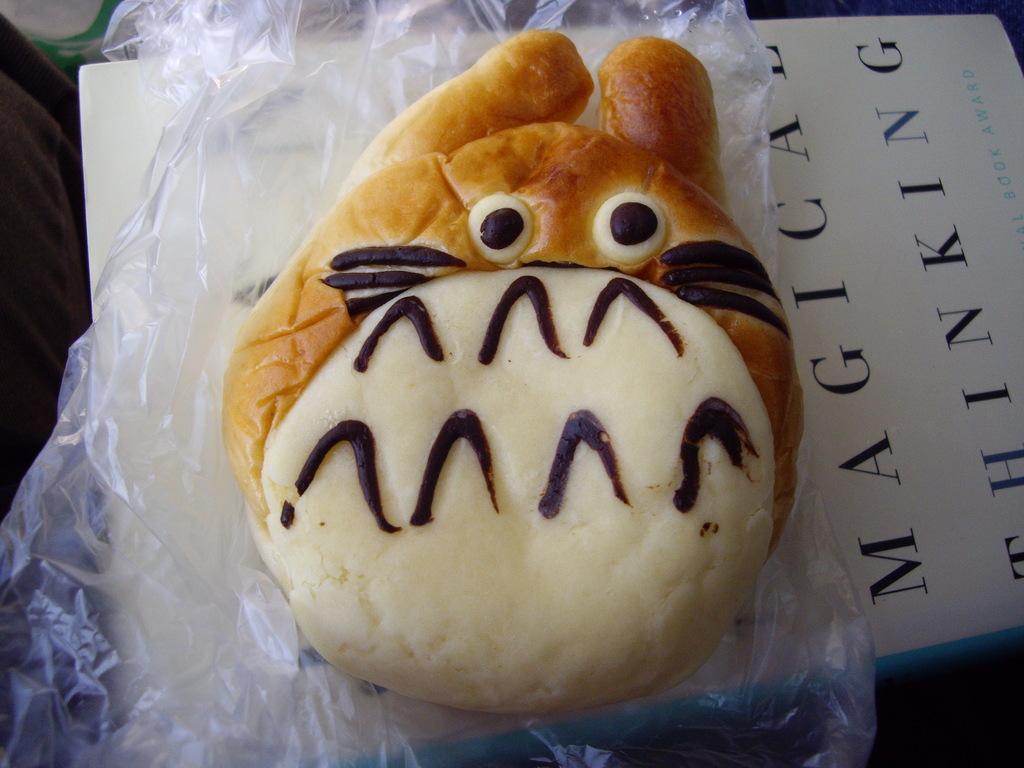Can you describe this image briefly? There is a baked food item kept on a cover as we can see in the middle of this image. We can see the cover is kept on a white color paper. 